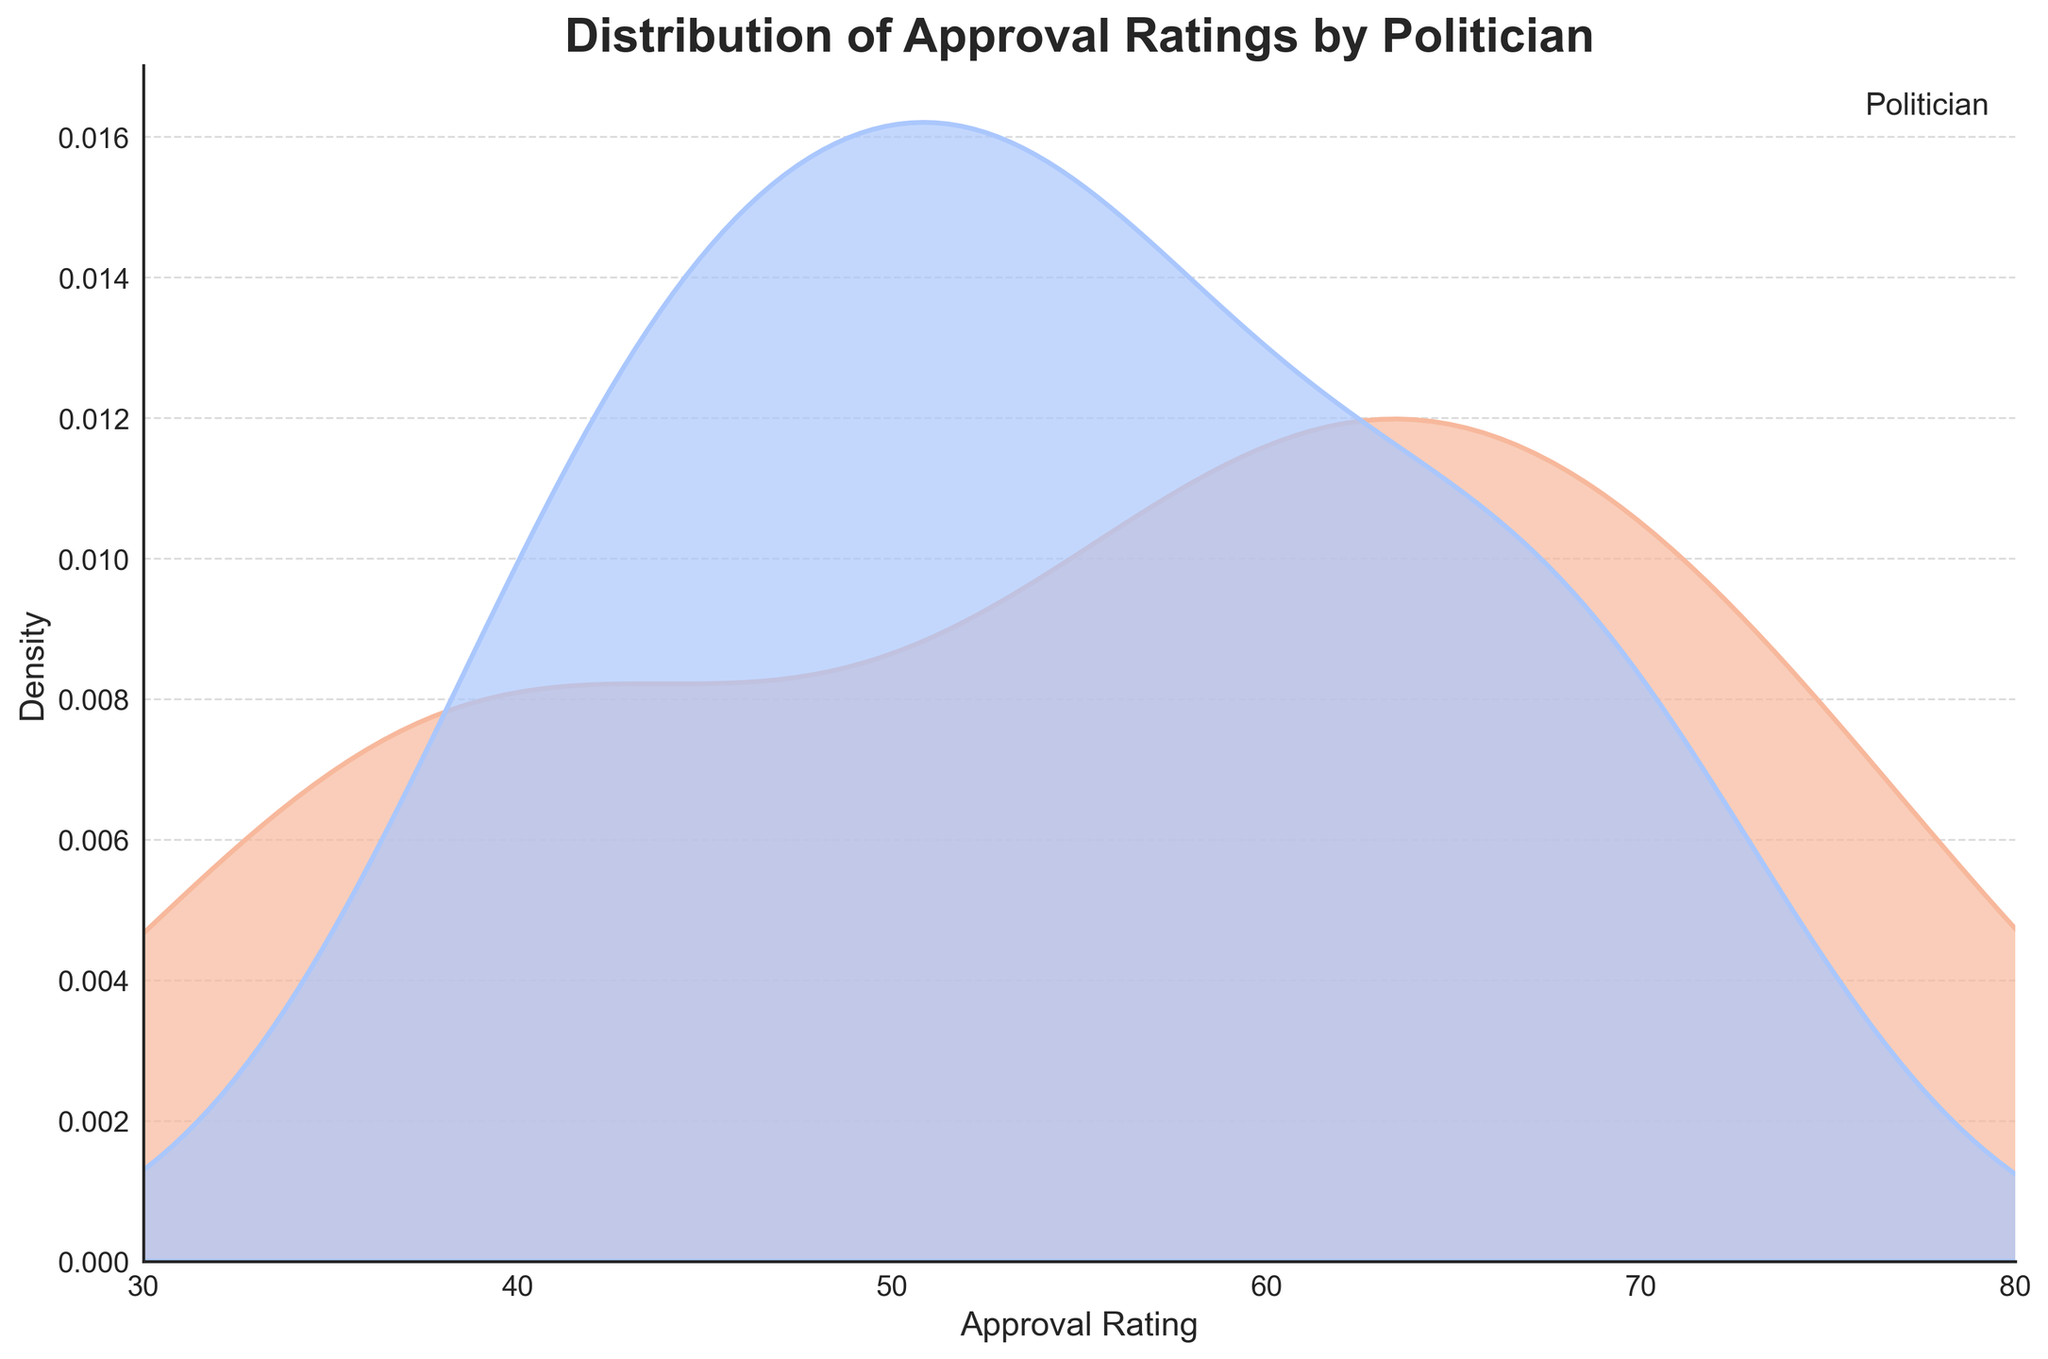What's the title of the plot? The title is located at the top of the plot, usually in a larger and bold font. It reads, 'Distribution of Approval Ratings by Politician.'
Answer: Distribution of Approval Ratings by Politician What do the x-axis and y-axis represent? The x-axis is labeled 'Approval Rating,' indicating it measures approval ratings. The y-axis is labeled 'Density,' showing it measures the density of those approval ratings.
Answer: x-axis: Approval Rating, y-axis: Density Which politician has the highest peak density in the plot? To find the highest peak density, look for the tallest curve on the plot. The hue indicates politicians; find the highest point in each colored curve. Jane Smith's curve, represented by a cool color (likely blue), has the highest density peak.
Answer: Jane Smith How is the approval rating distributed differently between the two politicians? Look at the shape and spread of the curves for each politician. Both curves overlap, but Jane Smith's curve tends to have higher peaks around the mid to high approval ratings, whereas John Doe's peaks are slightly lower and spread out.
Answer: Jane Smith has higher peaks in the mid-high range Between which approval ratings does John Doe's density curve mostly lie? To determine where John Doe's density lies, observe the shaded region along the x-axis for the 'John Doe' line. It spans approximately from 40 to 70.
Answer: 40 to 70 How do the curves for John Doe and Jane Smith compare at an approval rating of 60? Locate the approval rating of 60 on the x-axis and trace vertically to see where each curve intersects. The density for Jane Smith is higher than for John Doe at this point, indicated by a taller curve for Jane Smith.
Answer: Jane Smith's density is higher Are there any approval ratings where John Doe's density is higher than Jane Smith's? Identify where John Doe's curve exceeds Jane Smith's throughout the x-axis. This is seen around the approval ratings of 45-50.
Answer: Around 45-50 What can you infer about the overall spread and concentration of approval ratings for each politician? Look at the width and peak of each curve to understand how ratings are spread out. John Doe's curve is wider and less concentrated, suggesting more varied ratings. Jane Smith's curve is narrower and peaked, indicating more consistent high ratings.
Answer: John Doe: varied ratings, Jane Smith: consistent high ratings How do the tails of the density curves compare for each politician in terms of approval ratings? Examine the ends of each curve on the lower and higher ends of the x-axis. Both politicians have curves that taper off towards the extremes, but Jane Smith's curve has longer, less steep tails, particularly on the lower end (below 40).
Answer: Jane Smith has longer tails 